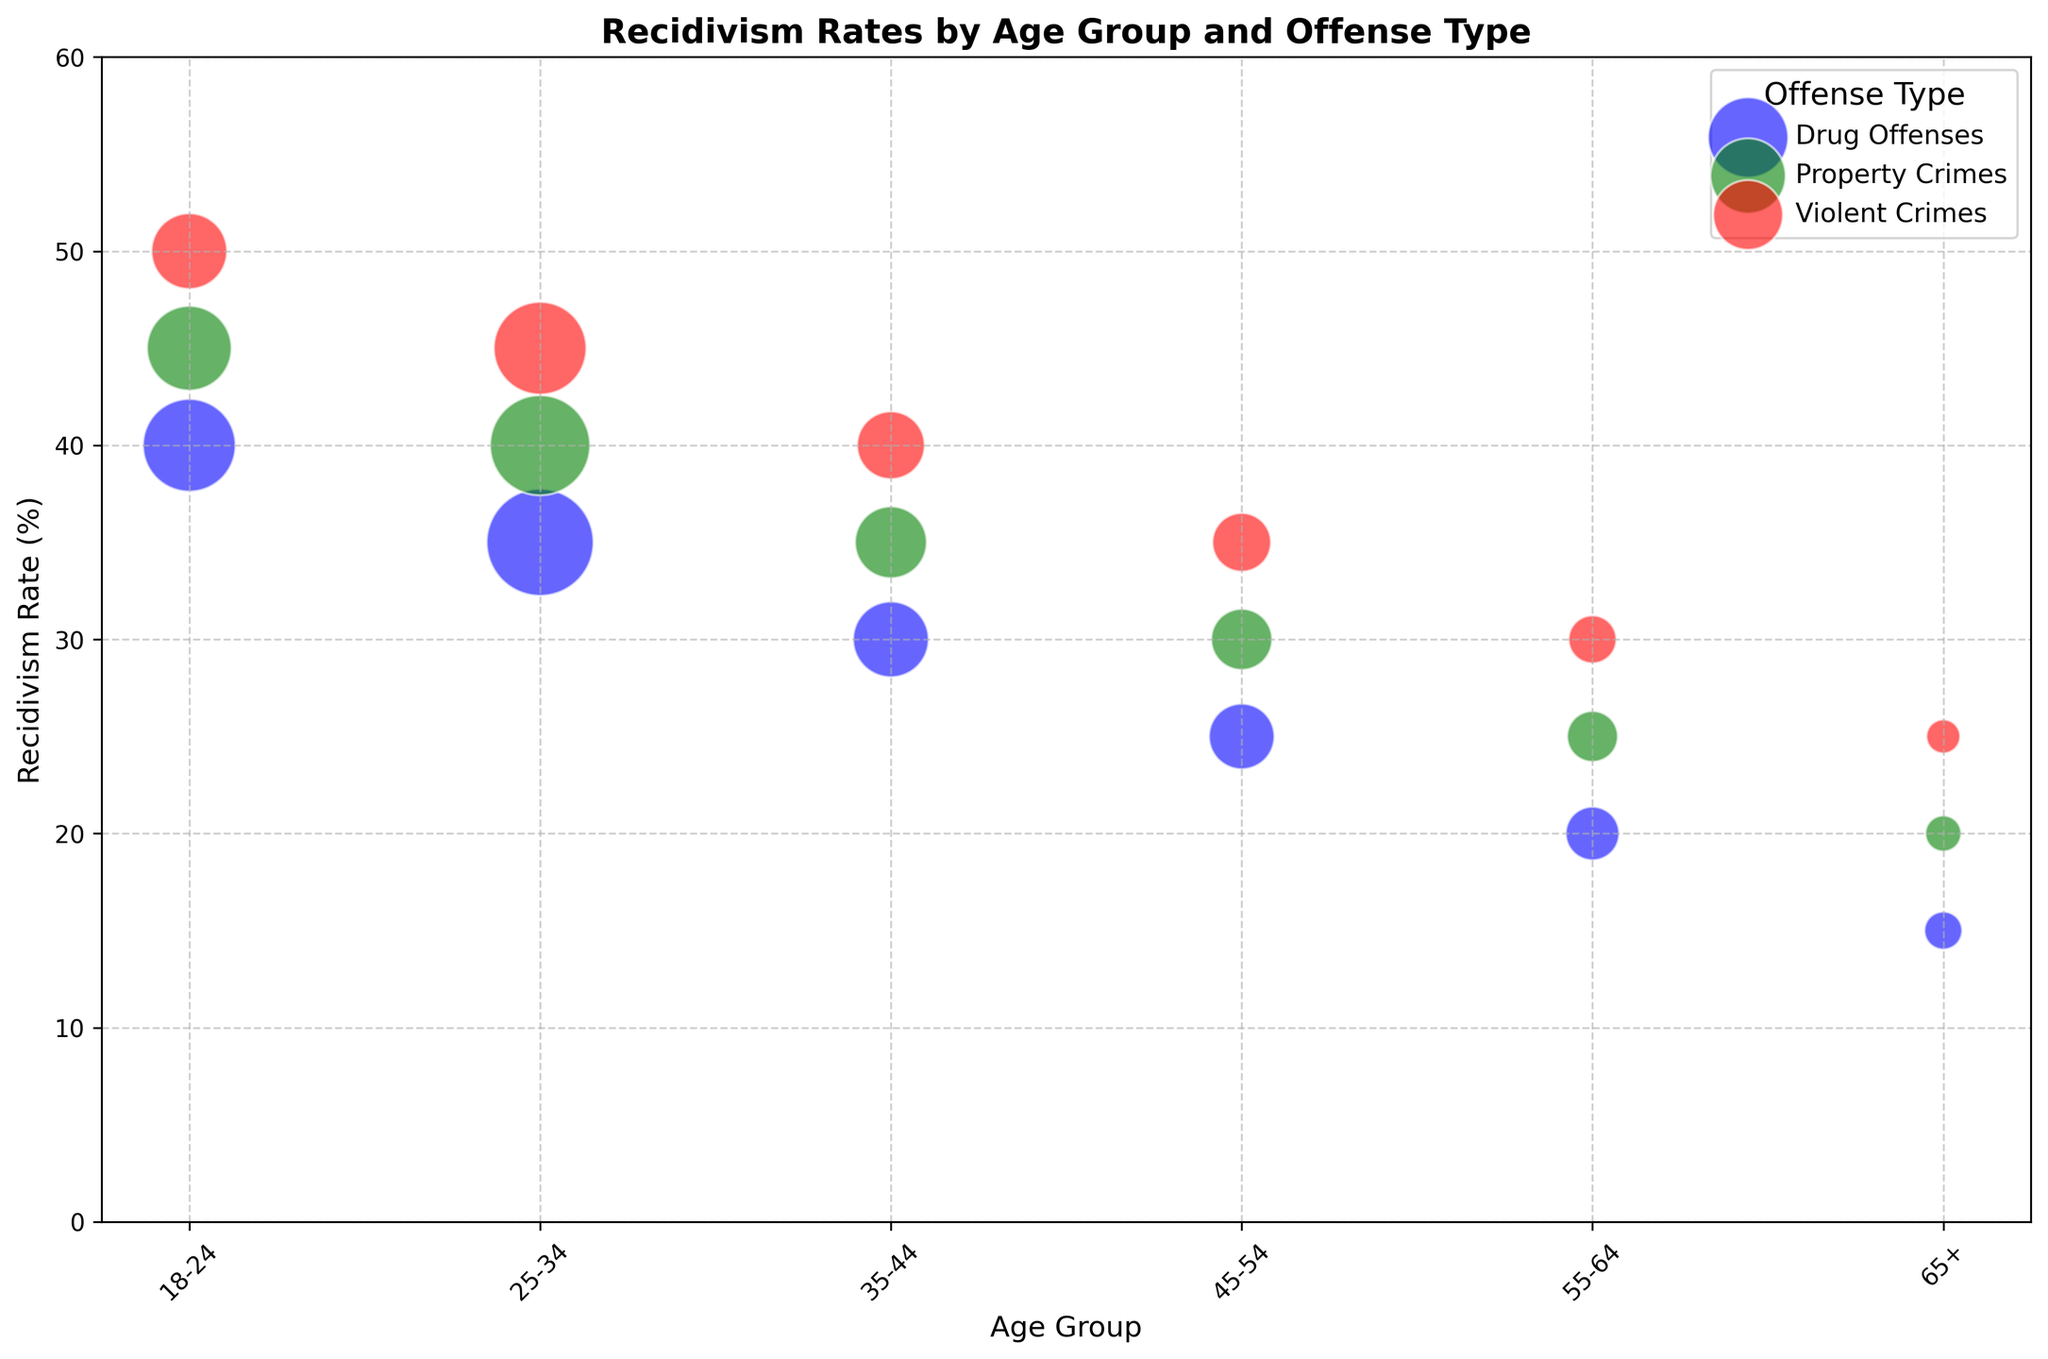What age group and offense type show the highest recidivism rate? Look at the plotted values and observe which age group and offense type have the highest point on the y-axis. The highest recidivism rate is observed for 18-24 age group with Violent Crimes.
Answer: 18-24, Violent Crimes Which offense type has a higher recidivism rate across all age groups: Property Crimes or Drug Offenses? For each age group, compare the y-axis values between Property Crimes and Drug Offenses. Property Crimes consistently have a higher recidivism rate than Drug Offenses across all age groups.
Answer: Property Crimes What is the average recidivism rate for Violent Crimes across all age groups? Sum the recidivism rates for Violent Crimes across all age groups and divide by the number of age groups. The rates are 50, 45, 40, 35, 30, and 25, adding up to 225. Dividing 225 by 6 gives the average rate of 37.5.
Answer: 37.5 How does the recidivism rate for Drug Offenses in the 18-24 age group compare to Drug Offenses in the 25-34 age group? Observe the position of the blue bubbles for these age groups: 18-24 has a rate of 40, and 25-34 has a rate of 35. 40 is greater than 35, so the rate is higher for 18-24.
Answer: Higher Which age group has the lowest recidivism rate for Violent Crimes? Look at the red bubbles and identify which age group has the lowest point on the y-axis. The 65+ age group has the lowest recidivism rate for Violent Crimes at 25.
Answer: 65+ What is the difference in recidivism rates between Property Crimes and Violent Crimes for the 35-44 age group? Identify the y-axis values for 35-44 in Property Crimes and Violent Crimes: 35 and 40, respectively. The difference is 40 - 35 = 5.
Answer: 5 Which age group has the largest number of offenders for Property Crimes? The bubble size represents the number of offenders. Look at the largest green bubble, which is for the 25-34 age group. The number of offenders is indicated as 350.
Answer: 25-34 What are the recidivism rates for Property Crimes across all age groups, and what is their sum? List the rates and sum them up: 45 (18-24), 40 (25-34), 35 (35-44), 30 (45-54), 25 (55-64), and 20 (65+). The sum is 45 + 40 + 35 + 30 + 25 + 20 = 195.
Answer: 195 Which offense type shows the most consistent recidivism rate across different age groups? Compare the relative spread of the y-axis values for each offense type color. Drug Offenses (blue) show rates of 40, 35, 30, 25, 20, and 15, with consistent decrements of 5.
Answer: Drug Offenses 